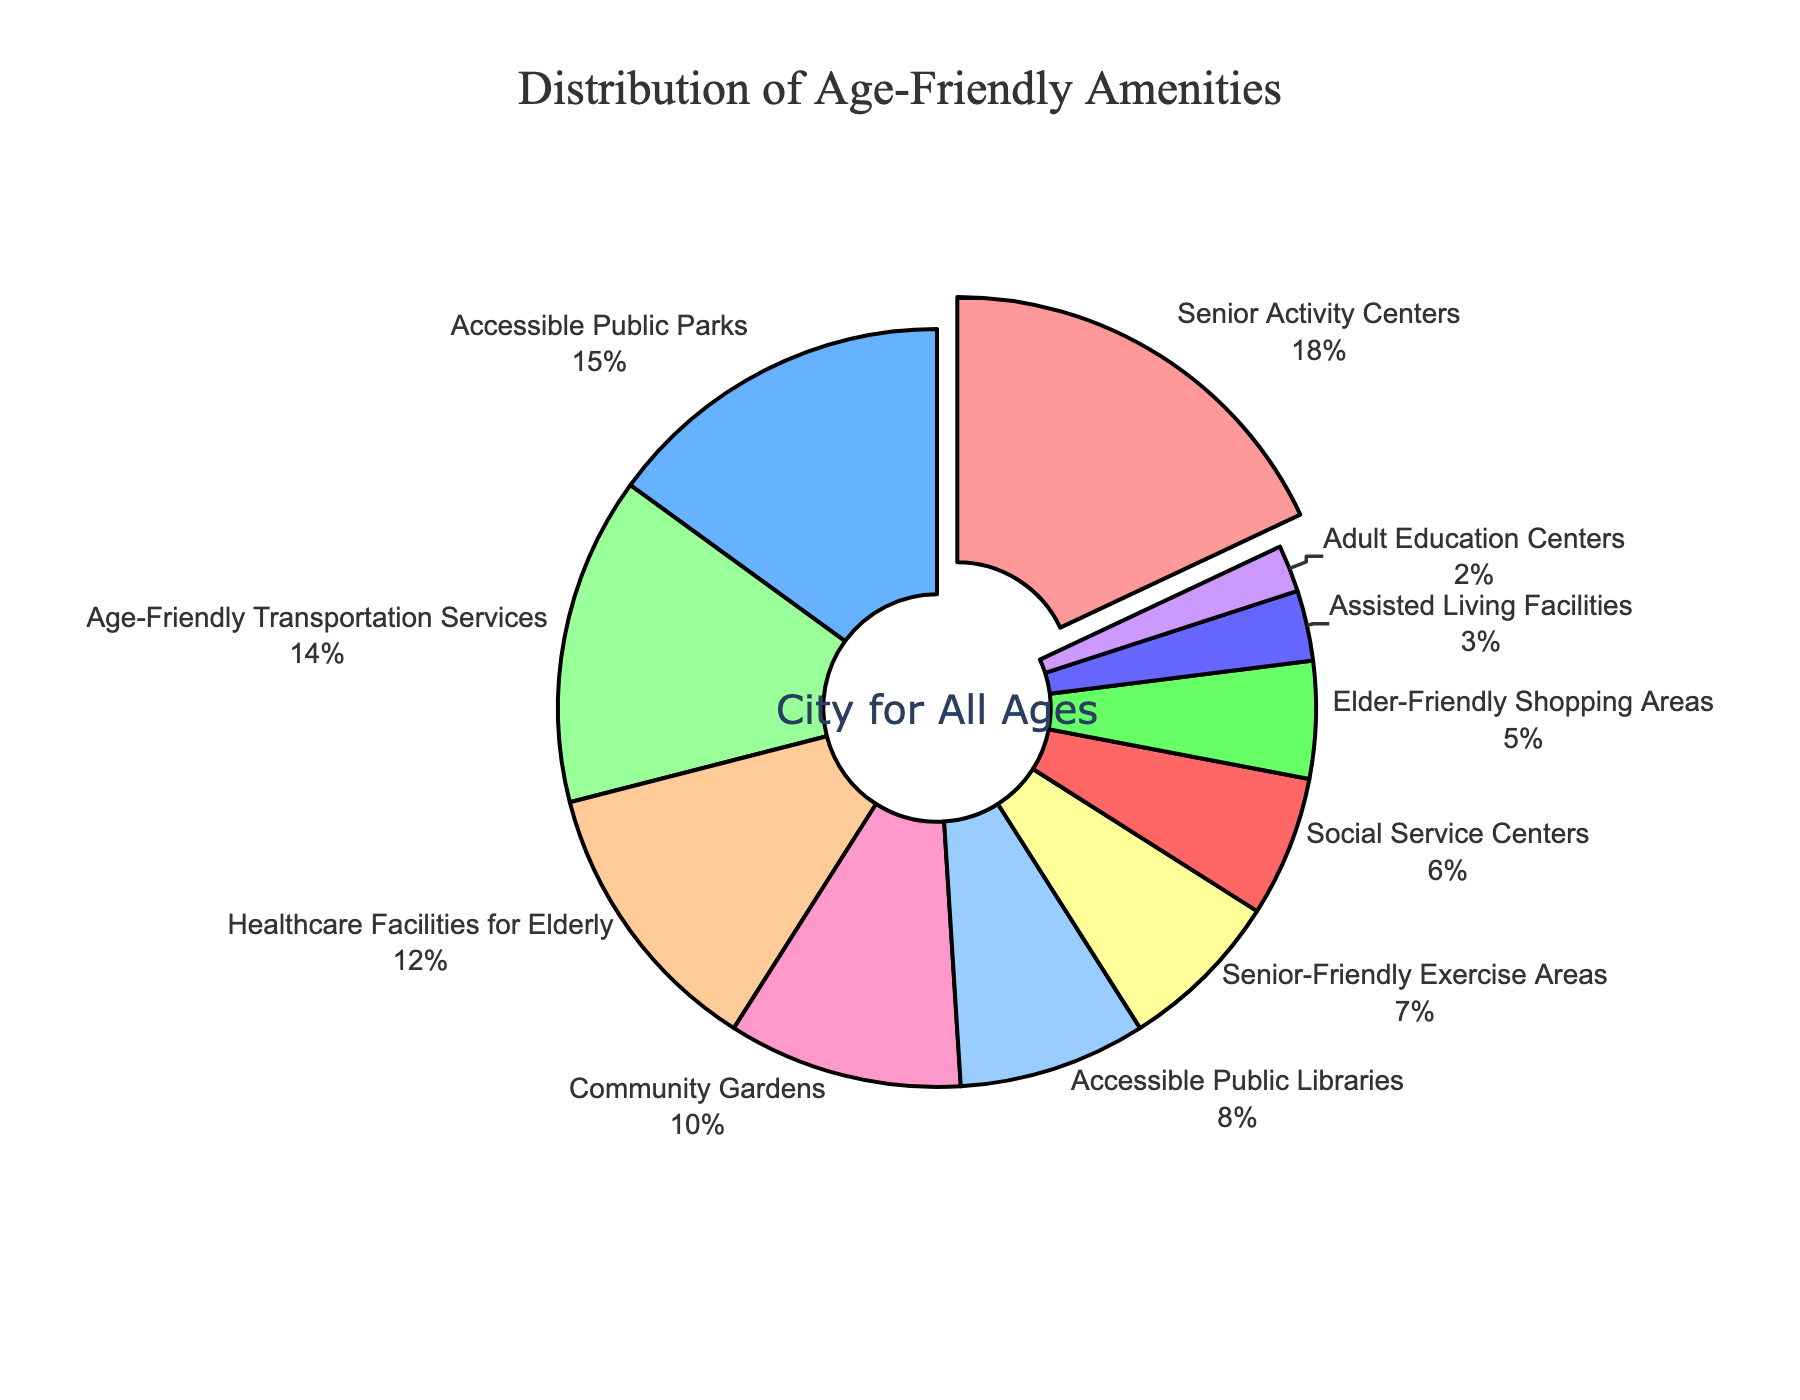What category has the highest percentage of amenities? By observing the chart, the category with the largest slice is labeled as Senior Activity Centers.
Answer: Senior Activity Centers Which two categories combined make up more than 30% of the amenities? Senior Activity Centers have 18% and Accessible Public Parks have 15%. Adding them together gives 33%, which is more than 30%.
Answer: Senior Activity Centers and Accessible Public Parks How much greater is the percentage of Senior Activity Centers compared to Assisted Living Facilities? Senior Activity Centers make up 18% and Assisted Living Facilities make up 3%. The difference is calculated as 18% - 3%, which is 15%.
Answer: 15% Are there more accessible public parks or age-friendly transportation services? Accessible Public Parks constitute 15% while Age-Friendly Transportation Services constitute 14%. By comparing these, Accessible Public Parks have a higher percentage.
Answer: Accessible Public Parks What is the combined percentage of Healthcare Facilities for Elderly and Community Gardens? Healthcare Facilities for Elderly form 12% and Community Gardens form 10%. Adding these, 12% + 10% = 22%.
Answer: 22% Which categories together form exactly 15% of the amenities? Social Service Centers form 6% and Elder-Friendly Shopping Areas form 5%, summing up to 11%. Adding Assisted Living Facilities, which is 3%, results in 14%. Only the Accessible Public Parks alone covers 15%.
Answer: Accessible Public Parks What is the percentage difference between Senior-Friendly Exercise Areas and Adult Education Centers? Senior-Friendly Exercise Areas make up 7% while Adult Education Centers make up 2%. The difference is calculated as 7% - 2%, which is 5%.
Answer: 5% How many categories constitute more than 10% individually? Observing the chart, Senior Activity Centers (18%), Accessible Public Parks (15%), Age-Friendly Transportation Services (14%), and Healthcare Facilities for Elderly (12%) are each more than 10%.
Answer: 4 Which category has the smallest slice? Referring to the chart, the smallest slice is labeled Adult Education Centers, which constitute 2%.
Answer: Adult Education Centers What is the difference in percentage between the largest and smallest categories? The largest category, Senior Activity Centers, has 18% and the smallest, Adult Education Centers, has 2%. The difference can be calculated as 18% - 2% = 16%.
Answer: 16% 